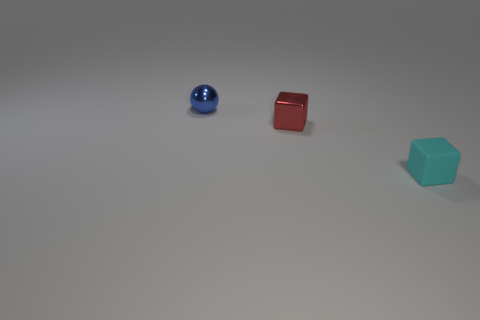Add 1 small brown rubber cylinders. How many objects exist? 4 Subtract all balls. How many objects are left? 2 Subtract 0 green blocks. How many objects are left? 3 Subtract all red objects. Subtract all spheres. How many objects are left? 1 Add 3 small red metal things. How many small red metal things are left? 4 Add 1 large rubber cylinders. How many large rubber cylinders exist? 1 